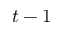<formula> <loc_0><loc_0><loc_500><loc_500>t - 1</formula> 